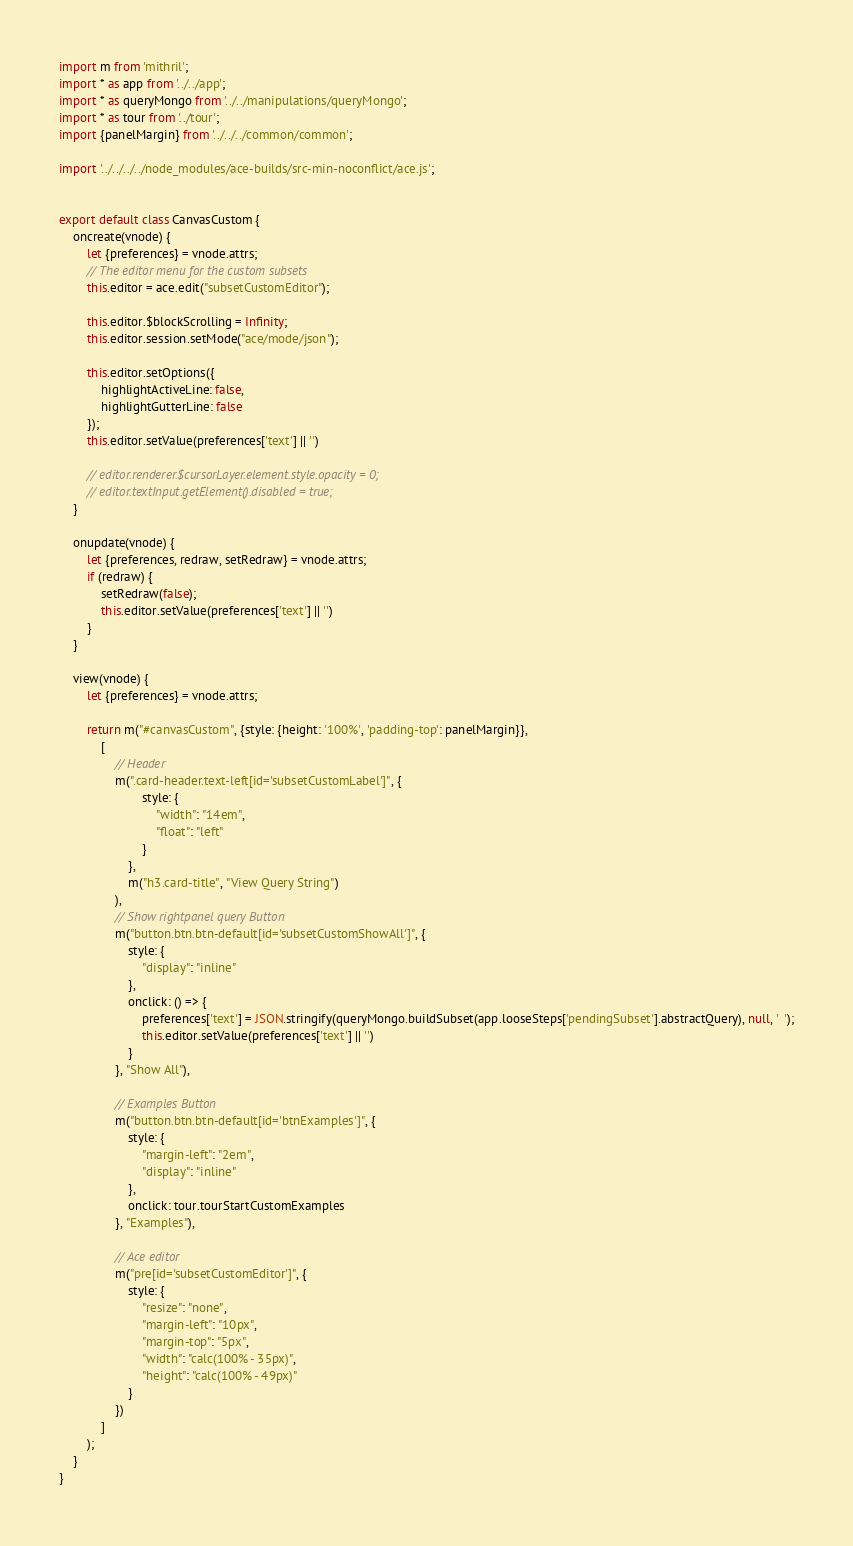Convert code to text. <code><loc_0><loc_0><loc_500><loc_500><_JavaScript_>import m from 'mithril';
import * as app from '../../app';
import * as queryMongo from '../../manipulations/queryMongo';
import * as tour from '../tour';
import {panelMargin} from '../../../common/common';

import '../../../../node_modules/ace-builds/src-min-noconflict/ace.js';


export default class CanvasCustom {
    oncreate(vnode) {
        let {preferences} = vnode.attrs;
        // The editor menu for the custom subsets
        this.editor = ace.edit("subsetCustomEditor");

        this.editor.$blockScrolling = Infinity;
        this.editor.session.setMode("ace/mode/json");

        this.editor.setOptions({
            highlightActiveLine: false,
            highlightGutterLine: false
        });
        this.editor.setValue(preferences['text'] || '')

        // editor.renderer.$cursorLayer.element.style.opacity = 0;
        // editor.textInput.getElement().disabled = true;
    }

    onupdate(vnode) {
        let {preferences, redraw, setRedraw} = vnode.attrs;
        if (redraw) {
            setRedraw(false);
            this.editor.setValue(preferences['text'] || '')
        }
    }

    view(vnode) {
        let {preferences} = vnode.attrs;

        return m("#canvasCustom", {style: {height: '100%', 'padding-top': panelMargin}},
            [
                // Header
                m(".card-header.text-left[id='subsetCustomLabel']", {
                        style: {
                            "width": "14em",
                            "float": "left"
                        }
                    },
                    m("h3.card-title", "View Query String")
                ),
                // Show rightpanel query Button
                m("button.btn.btn-default[id='subsetCustomShowAll']", {
                    style: {
                        "display": "inline"
                    },
                    onclick: () => {
                        preferences['text'] = JSON.stringify(queryMongo.buildSubset(app.looseSteps['pendingSubset'].abstractQuery), null, '  ');
                        this.editor.setValue(preferences['text'] || '')
                    }
                }, "Show All"),

                // Examples Button
                m("button.btn.btn-default[id='btnExamples']", {
                    style: {
                        "margin-left": "2em",
                        "display": "inline"
                    },
                    onclick: tour.tourStartCustomExamples
                }, "Examples"),

                // Ace editor
                m("pre[id='subsetCustomEditor']", {
                    style: {
                        "resize": "none",
                        "margin-left": "10px",
                        "margin-top": "5px",
                        "width": "calc(100% - 35px)",
                        "height": "calc(100% - 49px)"
                    }
                })
            ]
        );
    }
}</code> 